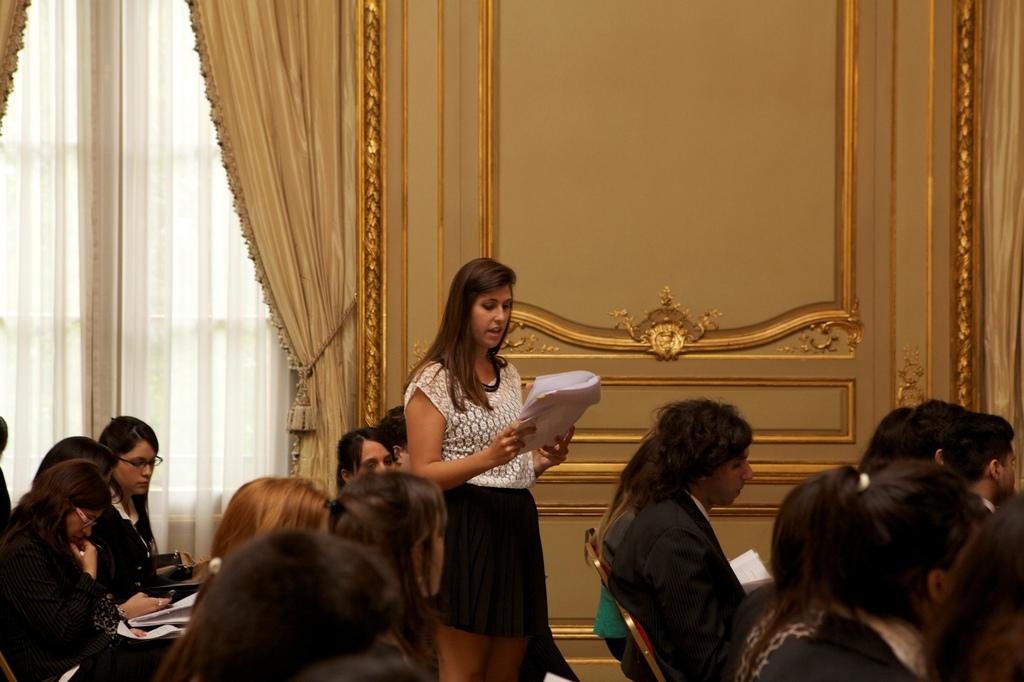What are the people in the image doing? There is a group of people sitting on chairs in the image. What is the woman in the image doing? The woman is standing in the image and holding papers. What can be seen in the background of the image? There are curtains and a wall in the background of the image. Can you tell me how many times the woman jumps in the image? There is no indication in the image that the woman is jumping; she is standing with papers. What type of guide is present in the image? There is no guide present in the image; it features a group of people sitting on chairs and a woman standing with papers. 